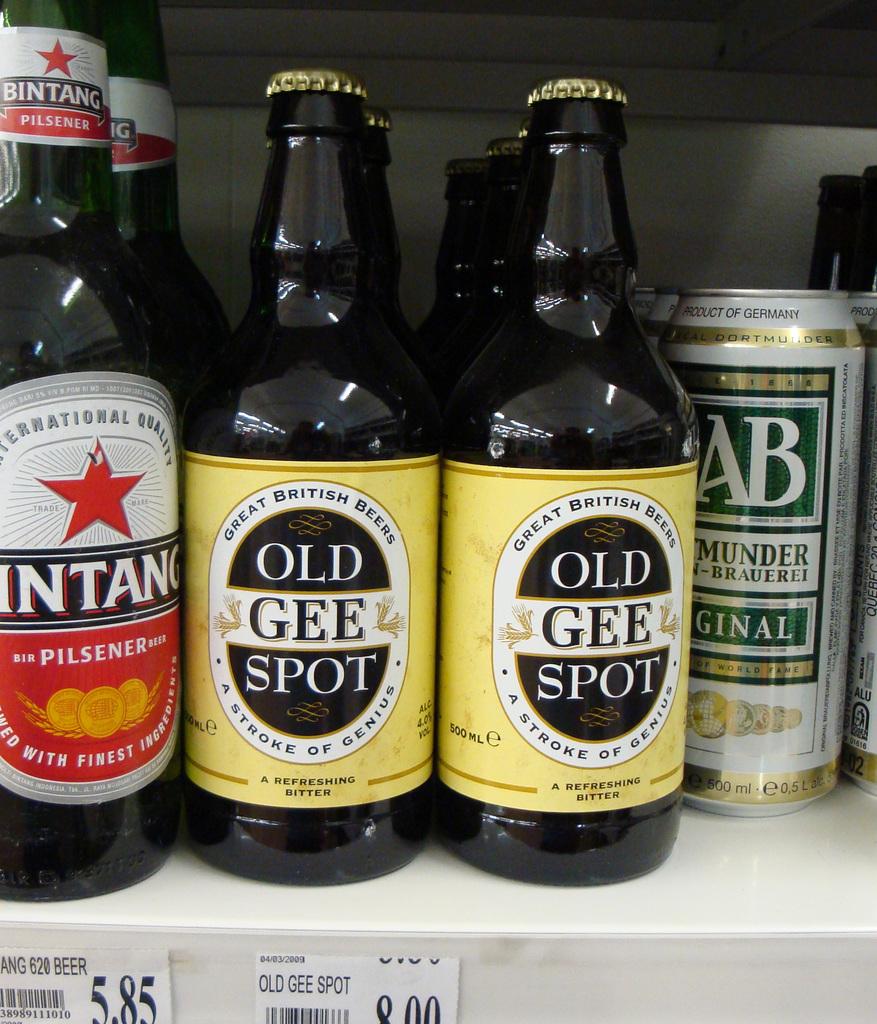Have you drank a pilsener before?
Ensure brevity in your answer.  Answering does not require reading text in the image. What is the name of the beverage in the middle?
Your answer should be very brief. Old gee spot. 